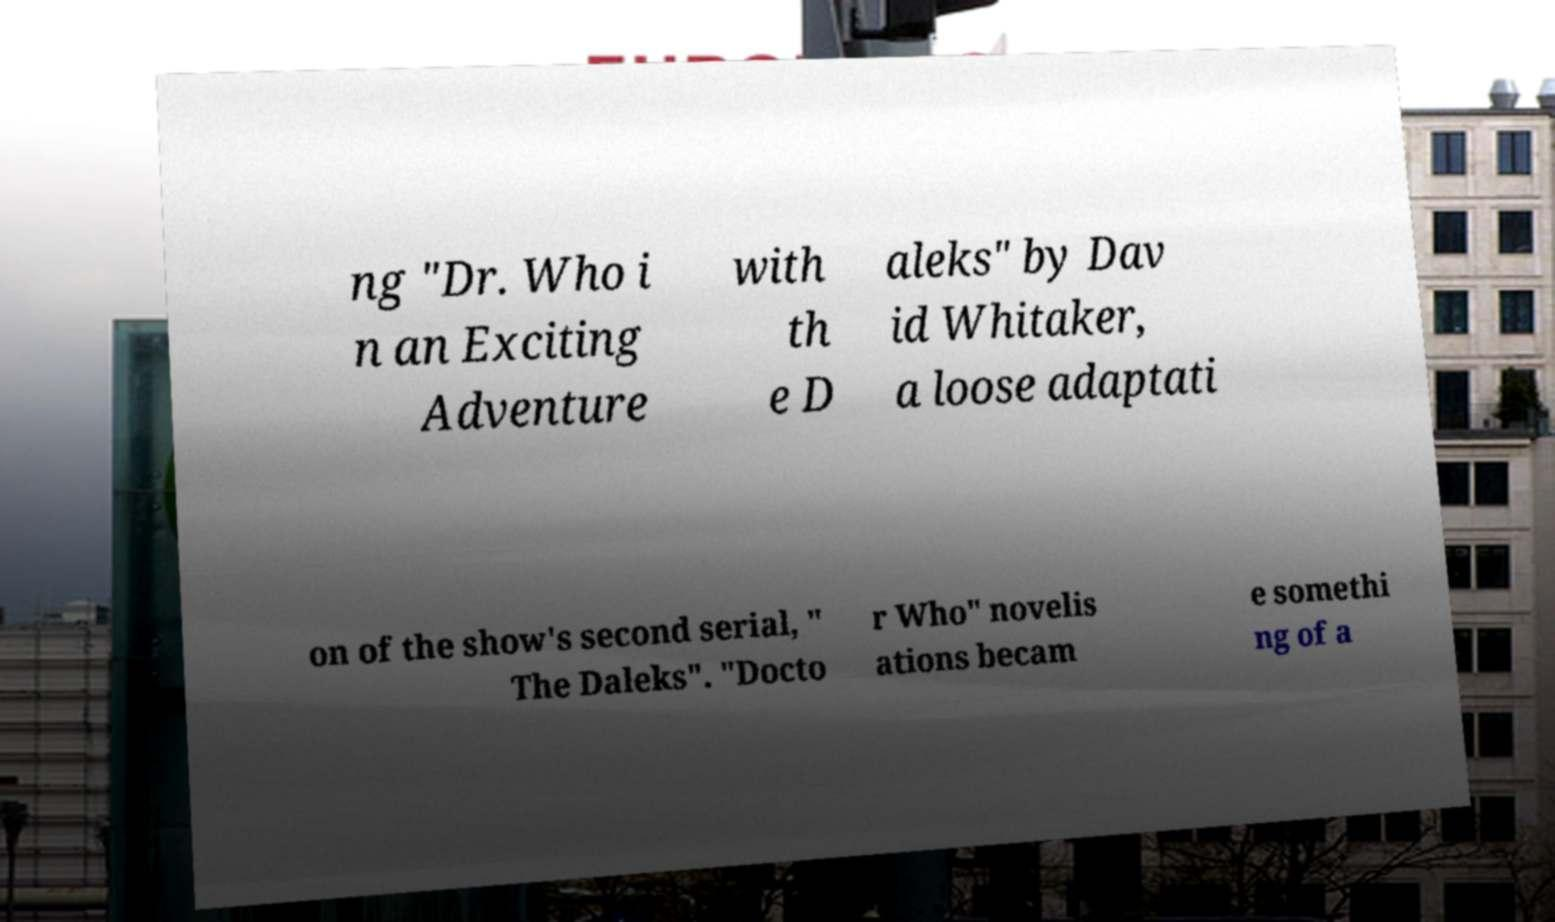Can you read and provide the text displayed in the image?This photo seems to have some interesting text. Can you extract and type it out for me? ng "Dr. Who i n an Exciting Adventure with th e D aleks" by Dav id Whitaker, a loose adaptati on of the show's second serial, " The Daleks". "Docto r Who" novelis ations becam e somethi ng of a 